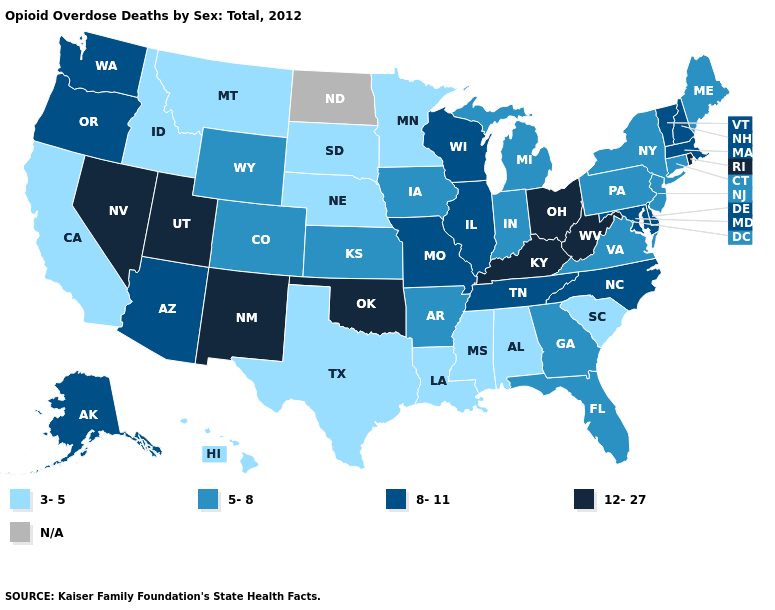What is the value of Georgia?
Keep it brief. 5-8. Name the states that have a value in the range 5-8?
Keep it brief. Arkansas, Colorado, Connecticut, Florida, Georgia, Indiana, Iowa, Kansas, Maine, Michigan, New Jersey, New York, Pennsylvania, Virginia, Wyoming. Name the states that have a value in the range 3-5?
Short answer required. Alabama, California, Hawaii, Idaho, Louisiana, Minnesota, Mississippi, Montana, Nebraska, South Carolina, South Dakota, Texas. Which states have the highest value in the USA?
Answer briefly. Kentucky, Nevada, New Mexico, Ohio, Oklahoma, Rhode Island, Utah, West Virginia. Does Massachusetts have the lowest value in the Northeast?
Keep it brief. No. What is the value of New Jersey?
Short answer required. 5-8. What is the highest value in the Northeast ?
Answer briefly. 12-27. What is the lowest value in the USA?
Answer briefly. 3-5. Name the states that have a value in the range 5-8?
Answer briefly. Arkansas, Colorado, Connecticut, Florida, Georgia, Indiana, Iowa, Kansas, Maine, Michigan, New Jersey, New York, Pennsylvania, Virginia, Wyoming. What is the lowest value in the MidWest?
Give a very brief answer. 3-5. Does Missouri have the lowest value in the MidWest?
Write a very short answer. No. What is the value of Wisconsin?
Short answer required. 8-11. What is the value of Alabama?
Concise answer only. 3-5. 